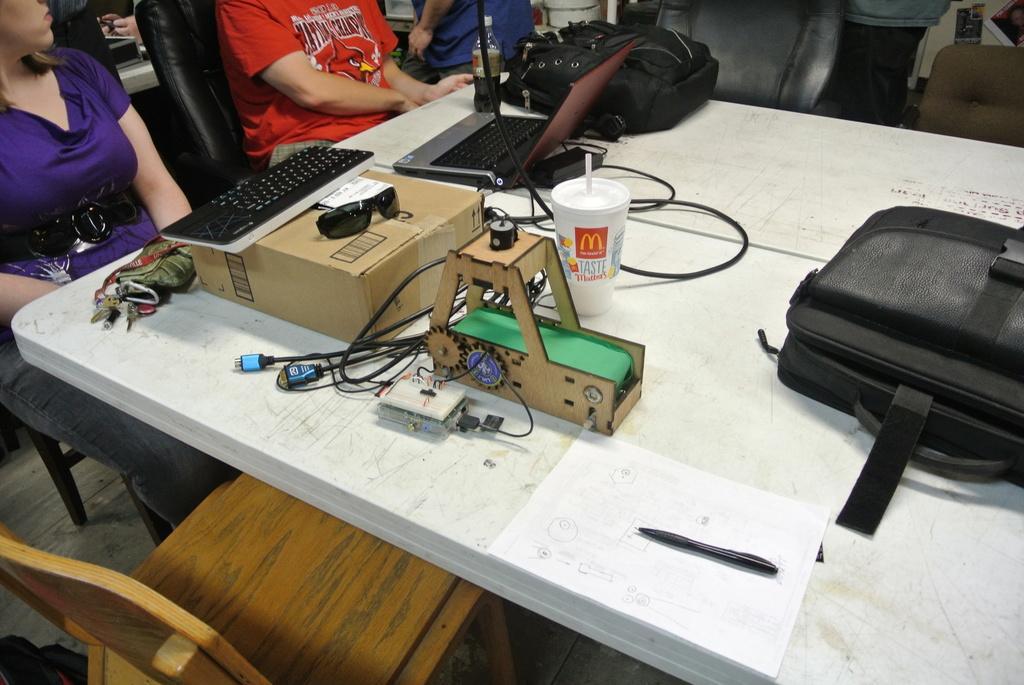Please provide a concise description of this image. In this image I can see a table on which we have a keyboard, laptop, bags and other objects on it. I can also see there are few people who are sitting on a chair. 